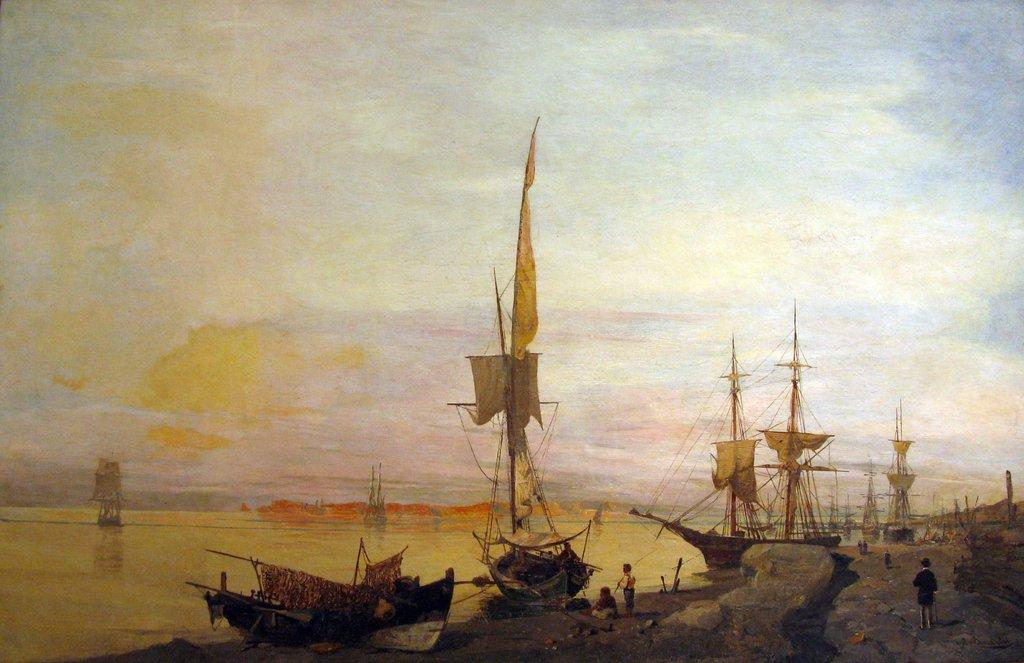What is depicted in the painting in the image? There is a painting of boats in the image. Where are the boats located in the painting? The boats are on the water in the painting. What else can be seen in the image besides the painting? There are people standing on the ground in the image. What is visible in the background of the image? The sky is visible in the background of the image. What type of stew is being cooked by the people in the image? There is no indication of cooking or stew in the image; it features a painting of boats and people standing on the ground. Can you tell me how many spacecraft are visible in the image? There are no spacecraft present in the image; it features a painting of boats on the water. 